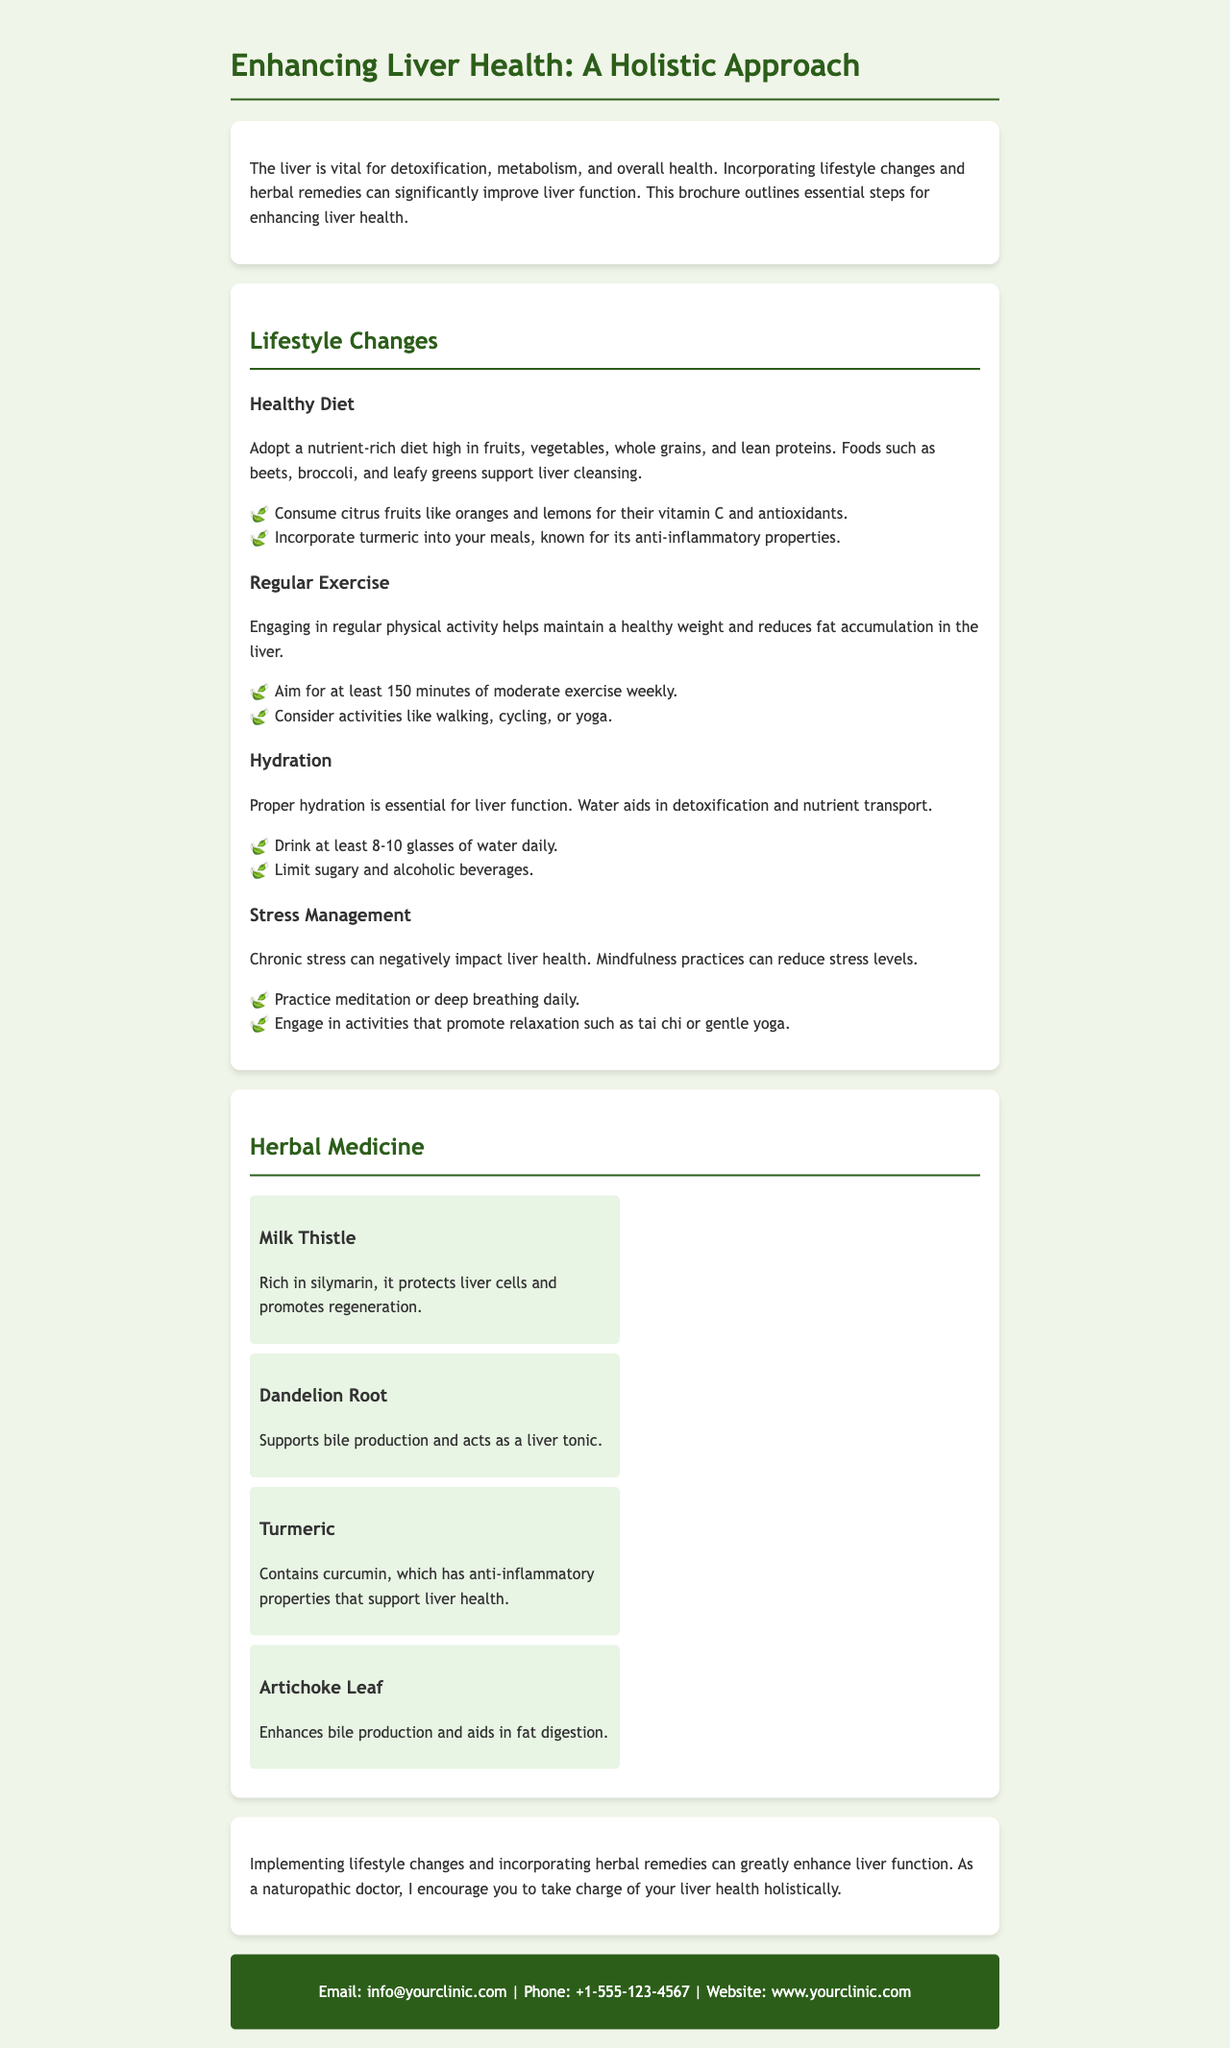What is the title of the brochure? The title of the brochure is presented at the top as a heading.
Answer: Enhancing Liver Health: A Holistic Approach What are the two main sections of the brochure? The document is organized into specific sections, each addressing different topics.
Answer: Lifestyle Changes, Herbal Medicine How many glasses of water should be consumed daily? The document specifies the recommended daily water intake for proper hydration.
Answer: 8-10 glasses What is the active compound in Milk Thistle? The document mentions the key component of Milk Thistle that benefits liver health.
Answer: Silymarin What kind of exercise is recommended weekly? The text provides a guideline for the amount of exercise recommended for maintaining liver health.
Answer: 150 minutes of moderate exercise Which herb is known for its anti-inflammatory properties? The document lists several herbs and specifies which one has anti-inflammatory benefits.
Answer: Turmeric What is the contact email provided in the brochure? The document contains specific contact information including an email for inquiries.
Answer: info@yourclinic.com What should be limited according to the hydration section? The hydration section cautions against specific types of beverages.
Answer: Sugary and alcoholic beverages Which herb supports bile production? The document describes several herbs and identifies one that aids in bile production.
Answer: Dandelion Root 